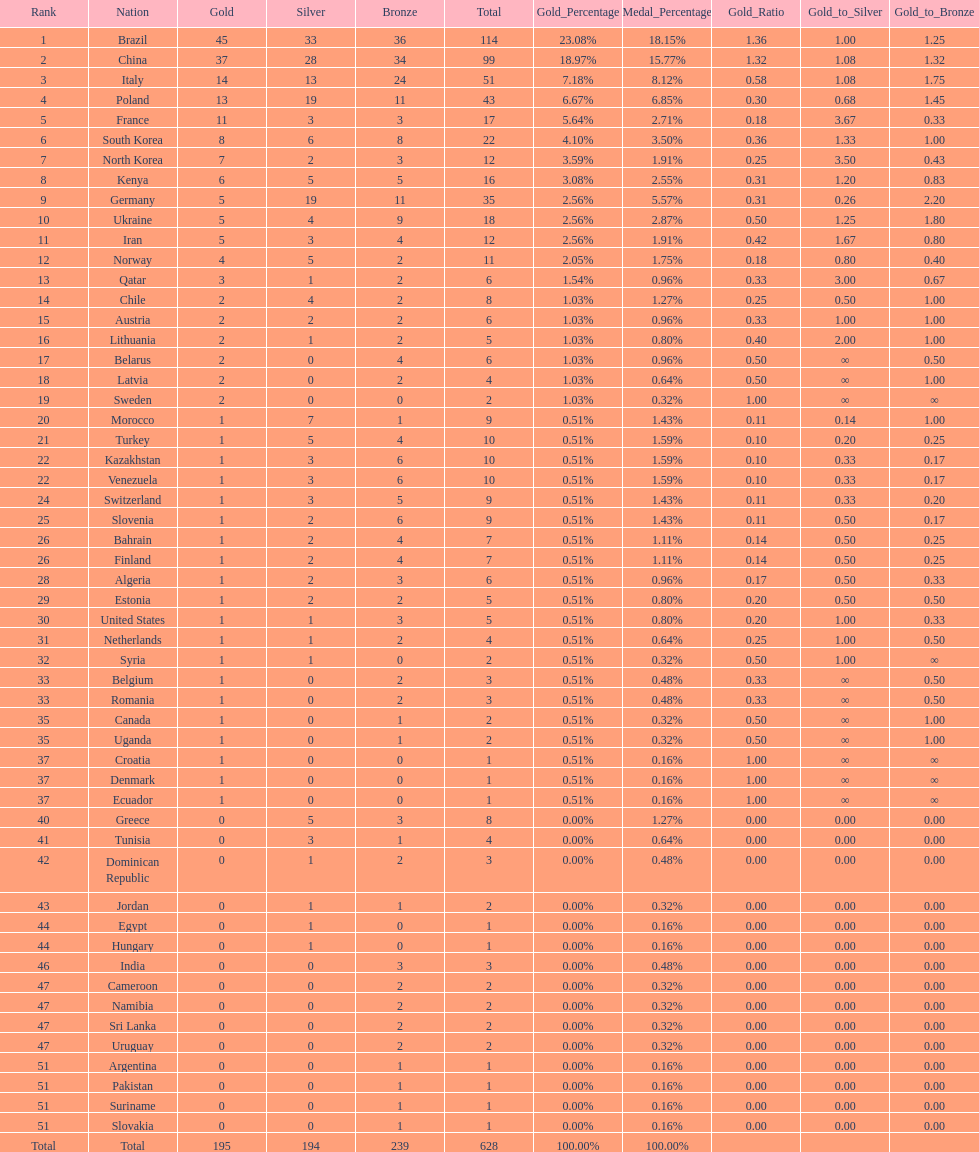How many gold medals did germany earn? 5. 